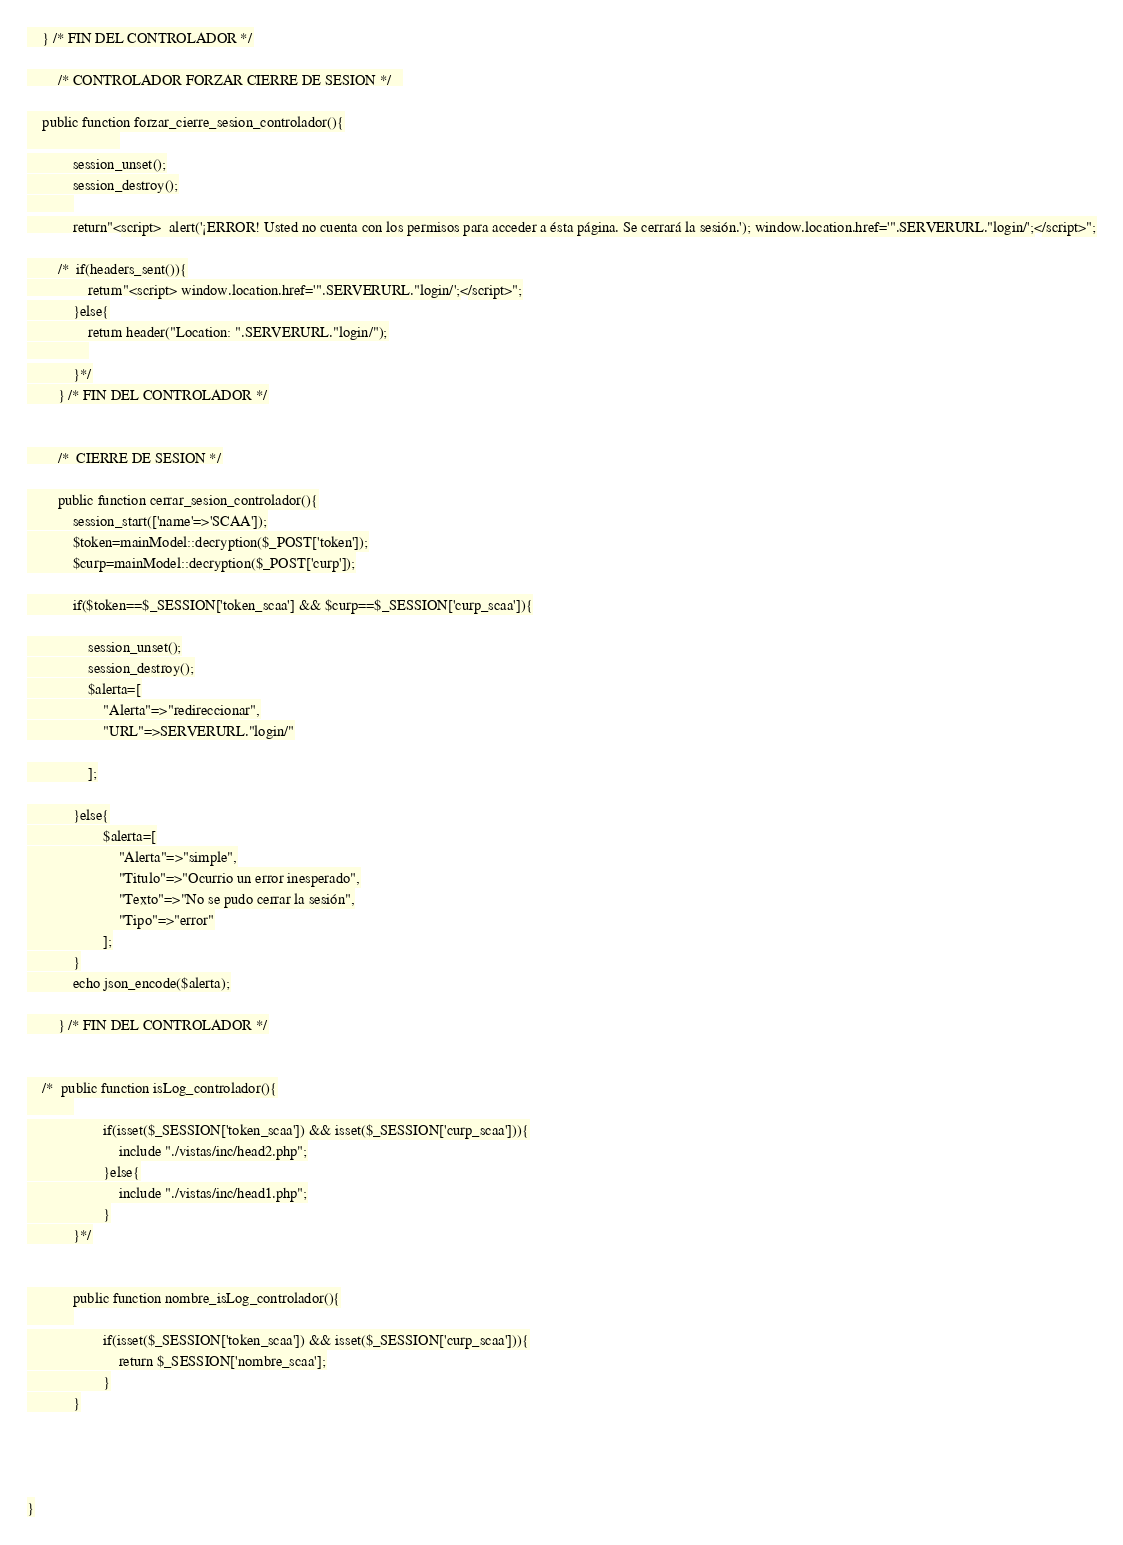Convert code to text. <code><loc_0><loc_0><loc_500><loc_500><_PHP_>	} /* FIN DEL CONTROLADOR */

		/* CONTROLADOR FORZAR CIERRE DE SESION */	

	public function forzar_cierre_sesion_controlador(){
						
			session_unset();
			session_destroy();
			
			return"<script>  alert('¡ERROR! Usted no cuenta con los permisos para acceder a ésta página. Se cerrará la sesión.'); window.location.href='".SERVERURL."login/';</script>";

		/*	if(headers_sent()){
				return"<script> window.location.href='".SERVERURL."login/';</script>";
			}else{
				return header("Location: ".SERVERURL."login/");
				
			}*/
		} /* FIN DEL CONTROLADOR */


		/*  CIERRE DE SESION */

		public function cerrar_sesion_controlador(){
			session_start(['name'=>'SCAA']);
			$token=mainModel::decryption($_POST['token']);
			$curp=mainModel::decryption($_POST['curp']);

			if($token==$_SESSION['token_scaa'] && $curp==$_SESSION['curp_scaa']){

				session_unset();
				session_destroy();
				$alerta=[
					"Alerta"=>"redireccionar",
					"URL"=>SERVERURL."login/"

				];

			}else{
					$alerta=[
						"Alerta"=>"simple",
						"Titulo"=>"Ocurrio un error inesperado",
						"Texto"=>"No se pudo cerrar la sesión",
						"Tipo"=>"error"
					];
			}
			echo json_encode($alerta);

		} /* FIN DEL CONTROLADOR */


	/*	public function isLog_controlador(){
			
					if(isset($_SESSION['token_scaa']) && isset($_SESSION['curp_scaa'])){
						include "./vistas/inc/head2.php";
					}else{
						include "./vistas/inc/head1.php";
					}
			}*/


			public function nombre_isLog_controlador(){
			
					if(isset($_SESSION['token_scaa']) && isset($_SESSION['curp_scaa'])){
						return $_SESSION['nombre_scaa'];
					}
			}




}</code> 